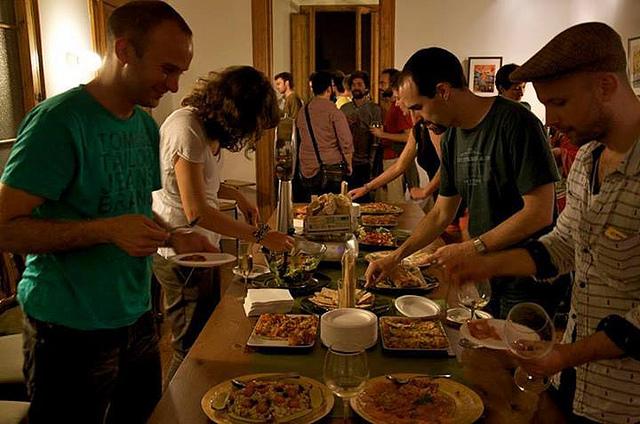On which wrist is the woman wearing a watch?
Concise answer only. Right. Are these people working?
Short answer required. No. Do these people look hungry?
Write a very short answer. Yes. Do these people appear to be almost finished with their meal?
Quick response, please. No. What color is the person on left's shirt?
Quick response, please. Green. What color is the mans t-shirt?
Answer briefly. Green. Are these people going to eat?
Give a very brief answer. Yes. Is a man holding a wine glass?
Answer briefly. Yes. Is this a concession stand?
Be succinct. No. What pattern is on the outfit of the woman in the center?
Quick response, please. Solid. How many people are here?
Write a very short answer. 10. What does there seem to be a large selection of here?
Write a very short answer. Food. Is there a colander on the table?
Concise answer only. No. What color are the plates?
Write a very short answer. White. Is this a cheese pie?
Short answer required. No. How many people?
Write a very short answer. 10. What type of plates are the people eating off of?
Concise answer only. Paper. 